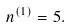Convert formula to latex. <formula><loc_0><loc_0><loc_500><loc_500>n ^ { ( 1 ) } = 5 .</formula> 